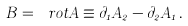Convert formula to latex. <formula><loc_0><loc_0><loc_500><loc_500>B = \ r o t A \equiv \partial _ { 1 } A _ { 2 } - \partial _ { 2 } A _ { 1 } \, .</formula> 